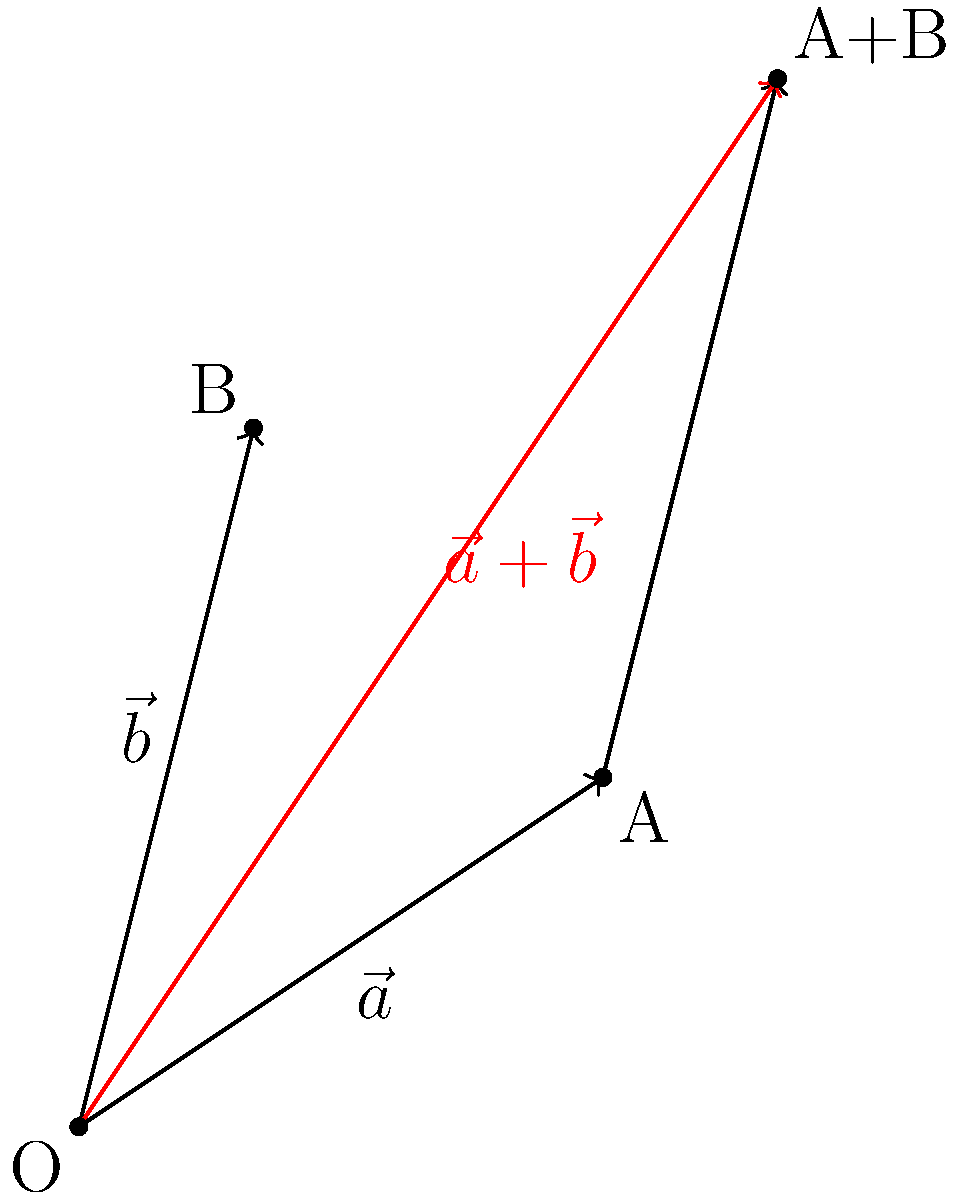Leah is learning about vector addition in her English language physics class. She encounters two vectors: $\vec{a} = 3\hat{i} + 2\hat{j}$ and $\vec{b} = \hat{i} + 4\hat{j}$. Can you help Leah find the magnitude of the resultant vector $\vec{r} = \vec{a} + \vec{b}$? Let's guide Leah through this step-by-step:

1) First, we need to add the two vectors:
   $\vec{r} = \vec{a} + \vec{b} = (3\hat{i} + 2\hat{j}) + (\hat{i} + 4\hat{j})$

2) We can combine like terms:
   $\vec{r} = (3+1)\hat{i} + (2+4)\hat{j} = 4\hat{i} + 6\hat{j}$

3) Now, we have the resultant vector $\vec{r} = 4\hat{i} + 6\hat{j}$

4) To find the magnitude, we use the Pythagorean theorem:
   $|\vec{r}| = \sqrt{x^2 + y^2}$, where $x$ and $y$ are the components of $\vec{r}$

5) Substituting our values:
   $|\vec{r}| = \sqrt{4^2 + 6^2} = \sqrt{16 + 36} = \sqrt{52}$

6) Simplify:
   $|\vec{r}| = \sqrt{52} = 2\sqrt{13}$

Therefore, the magnitude of the resultant vector is $2\sqrt{13}$ units.
Answer: $2\sqrt{13}$ 